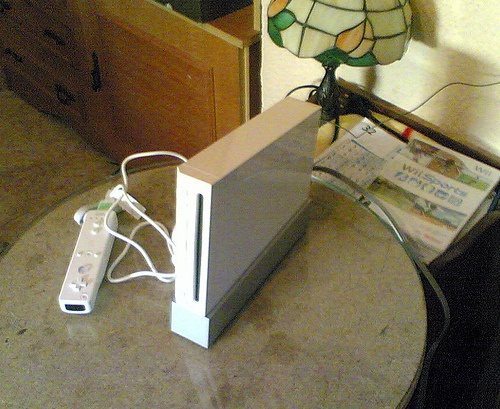Describe the objects in this image and their specific colors. I can see dining table in black, gray, and olive tones, book in black, tan, darkgray, gray, and olive tones, and remote in black, lightgray, darkgray, beige, and tan tones in this image. 